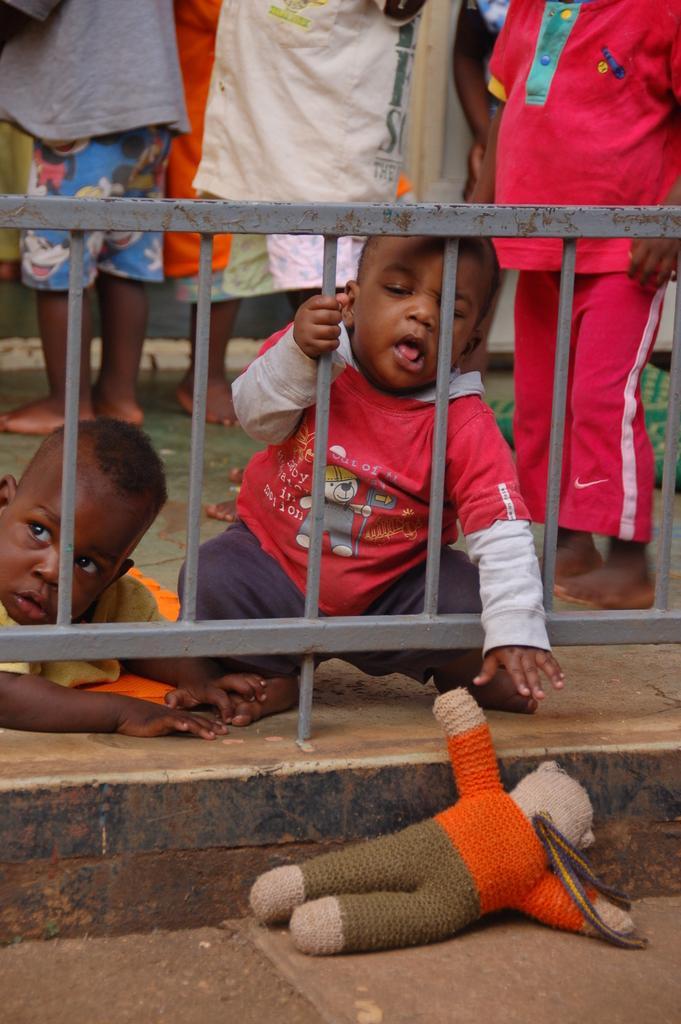Please provide a concise description of this image. In this image two kids are behind the fence. A toy is on the floor. Few persons are standing behind the fence. 